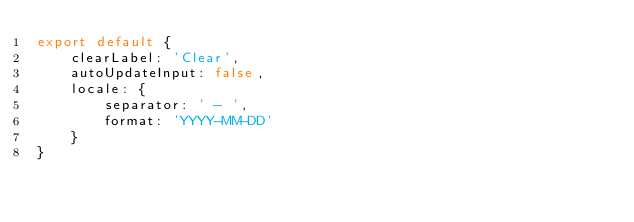<code> <loc_0><loc_0><loc_500><loc_500><_JavaScript_>export default {
    clearLabel: 'Clear',
    autoUpdateInput: false,
    locale: {
        separator: ' - ',
        format: 'YYYY-MM-DD'
    }
}
</code> 